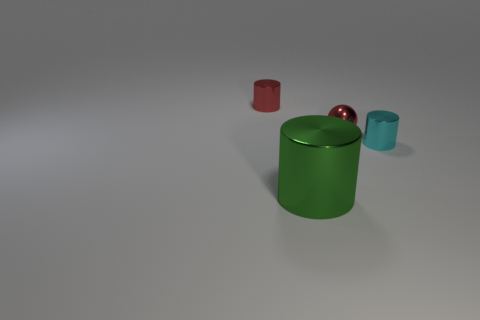Subtract all tiny metal cylinders. How many cylinders are left? 1 Add 2 big shiny spheres. How many objects exist? 6 Subtract all cylinders. How many objects are left? 1 Subtract 0 gray cylinders. How many objects are left? 4 Subtract all yellow cylinders. Subtract all purple cubes. How many cylinders are left? 3 Subtract all blocks. Subtract all tiny red metal objects. How many objects are left? 2 Add 2 big metallic things. How many big metallic things are left? 3 Add 2 metallic cylinders. How many metallic cylinders exist? 5 